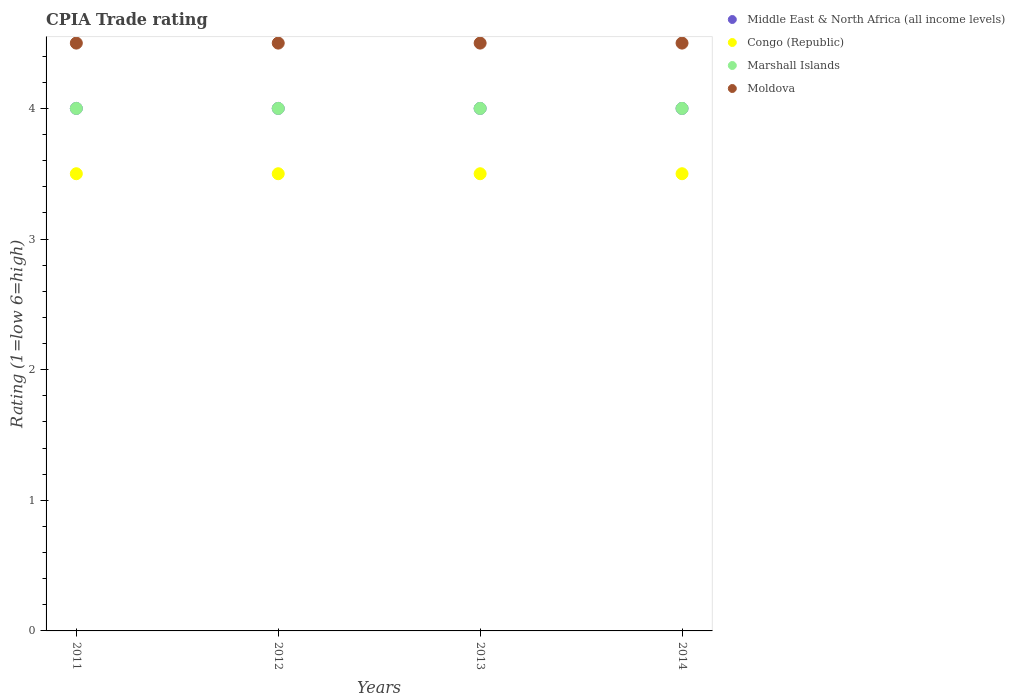Across all years, what is the maximum CPIA rating in Congo (Republic)?
Keep it short and to the point. 3.5. In which year was the CPIA rating in Moldova maximum?
Your response must be concise. 2011. What is the total CPIA rating in Congo (Republic) in the graph?
Keep it short and to the point. 14. What is the difference between the CPIA rating in Moldova in 2012 and that in 2013?
Offer a very short reply. 0. In the year 2014, what is the difference between the CPIA rating in Middle East & North Africa (all income levels) and CPIA rating in Marshall Islands?
Provide a succinct answer. 0. Is the CPIA rating in Middle East & North Africa (all income levels) in 2011 less than that in 2013?
Provide a succinct answer. No. Is the difference between the CPIA rating in Middle East & North Africa (all income levels) in 2012 and 2013 greater than the difference between the CPIA rating in Marshall Islands in 2012 and 2013?
Your response must be concise. No. What is the difference between the highest and the second highest CPIA rating in Moldova?
Offer a very short reply. 0. What is the difference between the highest and the lowest CPIA rating in Middle East & North Africa (all income levels)?
Ensure brevity in your answer.  0. In how many years, is the CPIA rating in Moldova greater than the average CPIA rating in Moldova taken over all years?
Provide a short and direct response. 0. Is the sum of the CPIA rating in Marshall Islands in 2011 and 2012 greater than the maximum CPIA rating in Moldova across all years?
Keep it short and to the point. Yes. Is it the case that in every year, the sum of the CPIA rating in Congo (Republic) and CPIA rating in Moldova  is greater than the sum of CPIA rating in Marshall Islands and CPIA rating in Middle East & North Africa (all income levels)?
Give a very brief answer. No. Is it the case that in every year, the sum of the CPIA rating in Marshall Islands and CPIA rating in Congo (Republic)  is greater than the CPIA rating in Moldova?
Provide a succinct answer. Yes. Is the CPIA rating in Moldova strictly greater than the CPIA rating in Marshall Islands over the years?
Offer a terse response. Yes. How many dotlines are there?
Offer a very short reply. 4. What is the difference between two consecutive major ticks on the Y-axis?
Your response must be concise. 1. Does the graph contain any zero values?
Keep it short and to the point. No. What is the title of the graph?
Your answer should be very brief. CPIA Trade rating. What is the label or title of the Y-axis?
Offer a terse response. Rating (1=low 6=high). What is the Rating (1=low 6=high) of Middle East & North Africa (all income levels) in 2012?
Your answer should be very brief. 4. What is the Rating (1=low 6=high) of Congo (Republic) in 2012?
Give a very brief answer. 3.5. What is the Rating (1=low 6=high) of Moldova in 2012?
Offer a very short reply. 4.5. What is the Rating (1=low 6=high) of Middle East & North Africa (all income levels) in 2013?
Offer a very short reply. 4. What is the Rating (1=low 6=high) in Middle East & North Africa (all income levels) in 2014?
Your answer should be very brief. 4. Across all years, what is the maximum Rating (1=low 6=high) in Middle East & North Africa (all income levels)?
Provide a short and direct response. 4. Across all years, what is the maximum Rating (1=low 6=high) in Marshall Islands?
Provide a succinct answer. 4. Across all years, what is the maximum Rating (1=low 6=high) in Moldova?
Provide a succinct answer. 4.5. Across all years, what is the minimum Rating (1=low 6=high) in Middle East & North Africa (all income levels)?
Ensure brevity in your answer.  4. Across all years, what is the minimum Rating (1=low 6=high) of Congo (Republic)?
Offer a very short reply. 3.5. What is the difference between the Rating (1=low 6=high) in Congo (Republic) in 2011 and that in 2012?
Your answer should be compact. 0. What is the difference between the Rating (1=low 6=high) in Marshall Islands in 2011 and that in 2012?
Your answer should be very brief. 0. What is the difference between the Rating (1=low 6=high) in Moldova in 2011 and that in 2012?
Provide a succinct answer. 0. What is the difference between the Rating (1=low 6=high) in Middle East & North Africa (all income levels) in 2011 and that in 2013?
Your answer should be compact. 0. What is the difference between the Rating (1=low 6=high) of Moldova in 2011 and that in 2013?
Your response must be concise. 0. What is the difference between the Rating (1=low 6=high) of Middle East & North Africa (all income levels) in 2011 and that in 2014?
Give a very brief answer. 0. What is the difference between the Rating (1=low 6=high) of Marshall Islands in 2011 and that in 2014?
Make the answer very short. 0. What is the difference between the Rating (1=low 6=high) in Moldova in 2012 and that in 2013?
Offer a very short reply. 0. What is the difference between the Rating (1=low 6=high) in Marshall Islands in 2012 and that in 2014?
Your answer should be very brief. 0. What is the difference between the Rating (1=low 6=high) in Moldova in 2012 and that in 2014?
Offer a very short reply. 0. What is the difference between the Rating (1=low 6=high) in Middle East & North Africa (all income levels) in 2013 and that in 2014?
Ensure brevity in your answer.  0. What is the difference between the Rating (1=low 6=high) of Congo (Republic) in 2013 and that in 2014?
Provide a short and direct response. 0. What is the difference between the Rating (1=low 6=high) in Moldova in 2013 and that in 2014?
Provide a succinct answer. 0. What is the difference between the Rating (1=low 6=high) of Middle East & North Africa (all income levels) in 2011 and the Rating (1=low 6=high) of Marshall Islands in 2012?
Offer a very short reply. 0. What is the difference between the Rating (1=low 6=high) of Middle East & North Africa (all income levels) in 2011 and the Rating (1=low 6=high) of Moldova in 2012?
Your answer should be very brief. -0.5. What is the difference between the Rating (1=low 6=high) of Middle East & North Africa (all income levels) in 2011 and the Rating (1=low 6=high) of Moldova in 2013?
Make the answer very short. -0.5. What is the difference between the Rating (1=low 6=high) in Congo (Republic) in 2011 and the Rating (1=low 6=high) in Marshall Islands in 2013?
Give a very brief answer. -0.5. What is the difference between the Rating (1=low 6=high) of Marshall Islands in 2011 and the Rating (1=low 6=high) of Moldova in 2013?
Your answer should be compact. -0.5. What is the difference between the Rating (1=low 6=high) in Middle East & North Africa (all income levels) in 2011 and the Rating (1=low 6=high) in Marshall Islands in 2014?
Give a very brief answer. 0. What is the difference between the Rating (1=low 6=high) in Congo (Republic) in 2011 and the Rating (1=low 6=high) in Marshall Islands in 2014?
Your answer should be very brief. -0.5. What is the difference between the Rating (1=low 6=high) of Congo (Republic) in 2011 and the Rating (1=low 6=high) of Moldova in 2014?
Your answer should be very brief. -1. What is the difference between the Rating (1=low 6=high) of Marshall Islands in 2011 and the Rating (1=low 6=high) of Moldova in 2014?
Make the answer very short. -0.5. What is the difference between the Rating (1=low 6=high) in Middle East & North Africa (all income levels) in 2012 and the Rating (1=low 6=high) in Marshall Islands in 2013?
Your answer should be very brief. 0. What is the difference between the Rating (1=low 6=high) of Congo (Republic) in 2012 and the Rating (1=low 6=high) of Moldova in 2013?
Give a very brief answer. -1. What is the difference between the Rating (1=low 6=high) in Middle East & North Africa (all income levels) in 2012 and the Rating (1=low 6=high) in Congo (Republic) in 2014?
Offer a very short reply. 0.5. What is the difference between the Rating (1=low 6=high) of Middle East & North Africa (all income levels) in 2012 and the Rating (1=low 6=high) of Moldova in 2014?
Your answer should be very brief. -0.5. What is the difference between the Rating (1=low 6=high) in Congo (Republic) in 2012 and the Rating (1=low 6=high) in Moldova in 2014?
Your answer should be compact. -1. What is the difference between the Rating (1=low 6=high) of Marshall Islands in 2012 and the Rating (1=low 6=high) of Moldova in 2014?
Give a very brief answer. -0.5. What is the difference between the Rating (1=low 6=high) of Middle East & North Africa (all income levels) in 2013 and the Rating (1=low 6=high) of Congo (Republic) in 2014?
Give a very brief answer. 0.5. What is the difference between the Rating (1=low 6=high) in Middle East & North Africa (all income levels) in 2013 and the Rating (1=low 6=high) in Moldova in 2014?
Offer a very short reply. -0.5. What is the difference between the Rating (1=low 6=high) of Congo (Republic) in 2013 and the Rating (1=low 6=high) of Marshall Islands in 2014?
Your response must be concise. -0.5. What is the average Rating (1=low 6=high) in Middle East & North Africa (all income levels) per year?
Make the answer very short. 4. What is the average Rating (1=low 6=high) in Congo (Republic) per year?
Your response must be concise. 3.5. In the year 2011, what is the difference between the Rating (1=low 6=high) in Middle East & North Africa (all income levels) and Rating (1=low 6=high) in Congo (Republic)?
Your response must be concise. 0.5. In the year 2011, what is the difference between the Rating (1=low 6=high) in Middle East & North Africa (all income levels) and Rating (1=low 6=high) in Moldova?
Provide a short and direct response. -0.5. In the year 2011, what is the difference between the Rating (1=low 6=high) of Congo (Republic) and Rating (1=low 6=high) of Marshall Islands?
Your answer should be compact. -0.5. In the year 2012, what is the difference between the Rating (1=low 6=high) of Middle East & North Africa (all income levels) and Rating (1=low 6=high) of Congo (Republic)?
Keep it short and to the point. 0.5. In the year 2012, what is the difference between the Rating (1=low 6=high) in Middle East & North Africa (all income levels) and Rating (1=low 6=high) in Marshall Islands?
Your answer should be very brief. 0. In the year 2013, what is the difference between the Rating (1=low 6=high) in Congo (Republic) and Rating (1=low 6=high) in Marshall Islands?
Provide a short and direct response. -0.5. In the year 2013, what is the difference between the Rating (1=low 6=high) of Marshall Islands and Rating (1=low 6=high) of Moldova?
Keep it short and to the point. -0.5. In the year 2014, what is the difference between the Rating (1=low 6=high) in Middle East & North Africa (all income levels) and Rating (1=low 6=high) in Congo (Republic)?
Keep it short and to the point. 0.5. In the year 2014, what is the difference between the Rating (1=low 6=high) in Middle East & North Africa (all income levels) and Rating (1=low 6=high) in Marshall Islands?
Your response must be concise. 0. In the year 2014, what is the difference between the Rating (1=low 6=high) of Middle East & North Africa (all income levels) and Rating (1=low 6=high) of Moldova?
Provide a succinct answer. -0.5. What is the ratio of the Rating (1=low 6=high) of Middle East & North Africa (all income levels) in 2011 to that in 2012?
Keep it short and to the point. 1. What is the ratio of the Rating (1=low 6=high) in Congo (Republic) in 2011 to that in 2012?
Your response must be concise. 1. What is the ratio of the Rating (1=low 6=high) in Middle East & North Africa (all income levels) in 2011 to that in 2013?
Offer a very short reply. 1. What is the ratio of the Rating (1=low 6=high) in Congo (Republic) in 2011 to that in 2013?
Provide a short and direct response. 1. What is the ratio of the Rating (1=low 6=high) of Marshall Islands in 2011 to that in 2013?
Keep it short and to the point. 1. What is the ratio of the Rating (1=low 6=high) in Moldova in 2011 to that in 2014?
Your response must be concise. 1. What is the ratio of the Rating (1=low 6=high) in Moldova in 2012 to that in 2013?
Your answer should be very brief. 1. What is the ratio of the Rating (1=low 6=high) in Congo (Republic) in 2012 to that in 2014?
Your answer should be very brief. 1. What is the ratio of the Rating (1=low 6=high) in Middle East & North Africa (all income levels) in 2013 to that in 2014?
Offer a terse response. 1. What is the ratio of the Rating (1=low 6=high) in Moldova in 2013 to that in 2014?
Your response must be concise. 1. What is the difference between the highest and the second highest Rating (1=low 6=high) in Congo (Republic)?
Your answer should be very brief. 0. What is the difference between the highest and the second highest Rating (1=low 6=high) in Moldova?
Provide a succinct answer. 0. What is the difference between the highest and the lowest Rating (1=low 6=high) in Middle East & North Africa (all income levels)?
Ensure brevity in your answer.  0. What is the difference between the highest and the lowest Rating (1=low 6=high) in Congo (Republic)?
Offer a terse response. 0. What is the difference between the highest and the lowest Rating (1=low 6=high) of Marshall Islands?
Your answer should be compact. 0. What is the difference between the highest and the lowest Rating (1=low 6=high) in Moldova?
Your response must be concise. 0. 